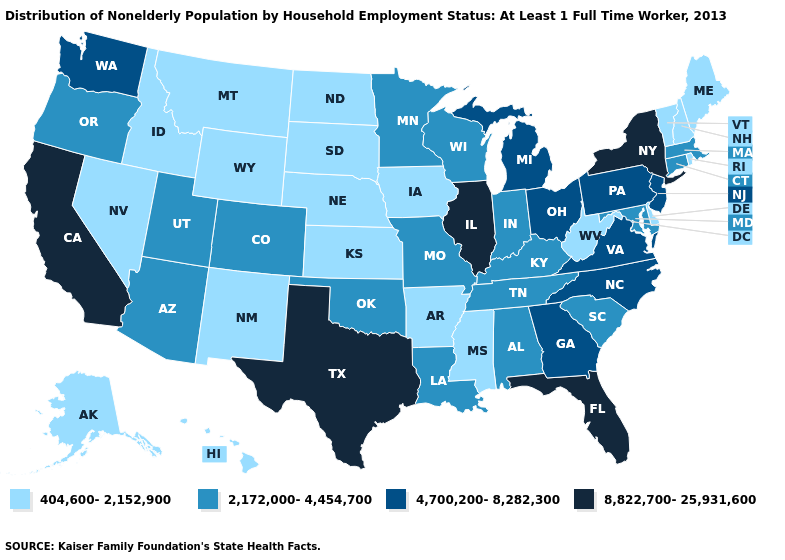Which states have the lowest value in the MidWest?
Keep it brief. Iowa, Kansas, Nebraska, North Dakota, South Dakota. Name the states that have a value in the range 404,600-2,152,900?
Give a very brief answer. Alaska, Arkansas, Delaware, Hawaii, Idaho, Iowa, Kansas, Maine, Mississippi, Montana, Nebraska, Nevada, New Hampshire, New Mexico, North Dakota, Rhode Island, South Dakota, Vermont, West Virginia, Wyoming. Name the states that have a value in the range 4,700,200-8,282,300?
Be succinct. Georgia, Michigan, New Jersey, North Carolina, Ohio, Pennsylvania, Virginia, Washington. Name the states that have a value in the range 404,600-2,152,900?
Keep it brief. Alaska, Arkansas, Delaware, Hawaii, Idaho, Iowa, Kansas, Maine, Mississippi, Montana, Nebraska, Nevada, New Hampshire, New Mexico, North Dakota, Rhode Island, South Dakota, Vermont, West Virginia, Wyoming. Name the states that have a value in the range 2,172,000-4,454,700?
Short answer required. Alabama, Arizona, Colorado, Connecticut, Indiana, Kentucky, Louisiana, Maryland, Massachusetts, Minnesota, Missouri, Oklahoma, Oregon, South Carolina, Tennessee, Utah, Wisconsin. Does Texas have a higher value than California?
Quick response, please. No. What is the value of Iowa?
Short answer required. 404,600-2,152,900. What is the value of Indiana?
Give a very brief answer. 2,172,000-4,454,700. Which states have the lowest value in the USA?
Give a very brief answer. Alaska, Arkansas, Delaware, Hawaii, Idaho, Iowa, Kansas, Maine, Mississippi, Montana, Nebraska, Nevada, New Hampshire, New Mexico, North Dakota, Rhode Island, South Dakota, Vermont, West Virginia, Wyoming. What is the value of Indiana?
Short answer required. 2,172,000-4,454,700. What is the lowest value in the South?
Give a very brief answer. 404,600-2,152,900. Does New Jersey have the highest value in the Northeast?
Give a very brief answer. No. Name the states that have a value in the range 404,600-2,152,900?
Write a very short answer. Alaska, Arkansas, Delaware, Hawaii, Idaho, Iowa, Kansas, Maine, Mississippi, Montana, Nebraska, Nevada, New Hampshire, New Mexico, North Dakota, Rhode Island, South Dakota, Vermont, West Virginia, Wyoming. What is the highest value in the MidWest ?
Write a very short answer. 8,822,700-25,931,600. Which states hav the highest value in the Northeast?
Keep it brief. New York. 